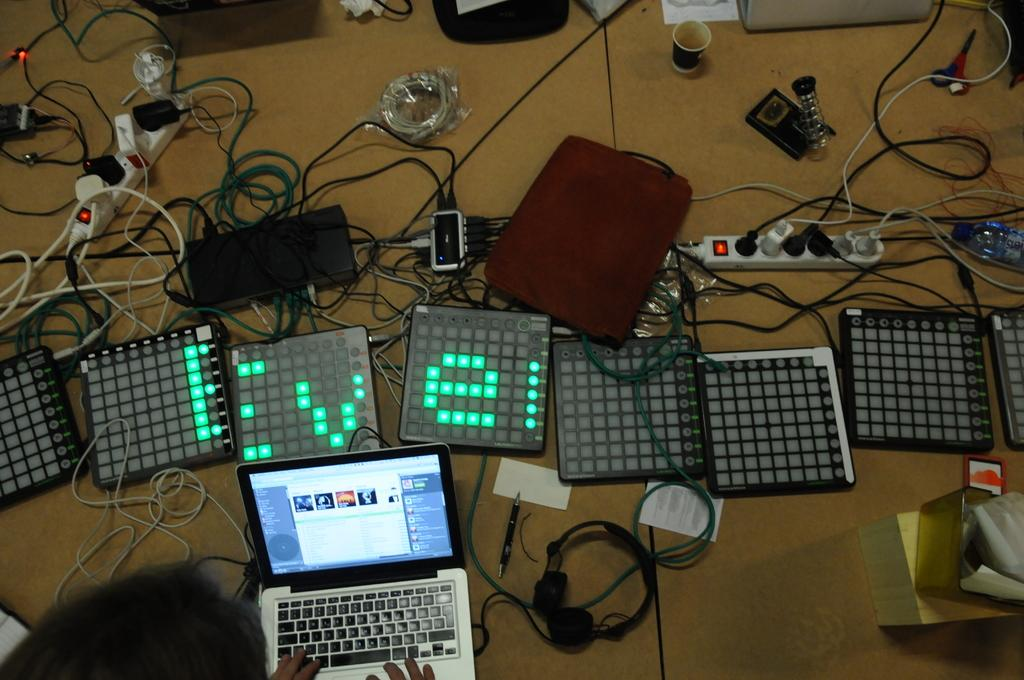Provide a one-sentence caption for the provided image. A set of digital display boards reads Eve. 